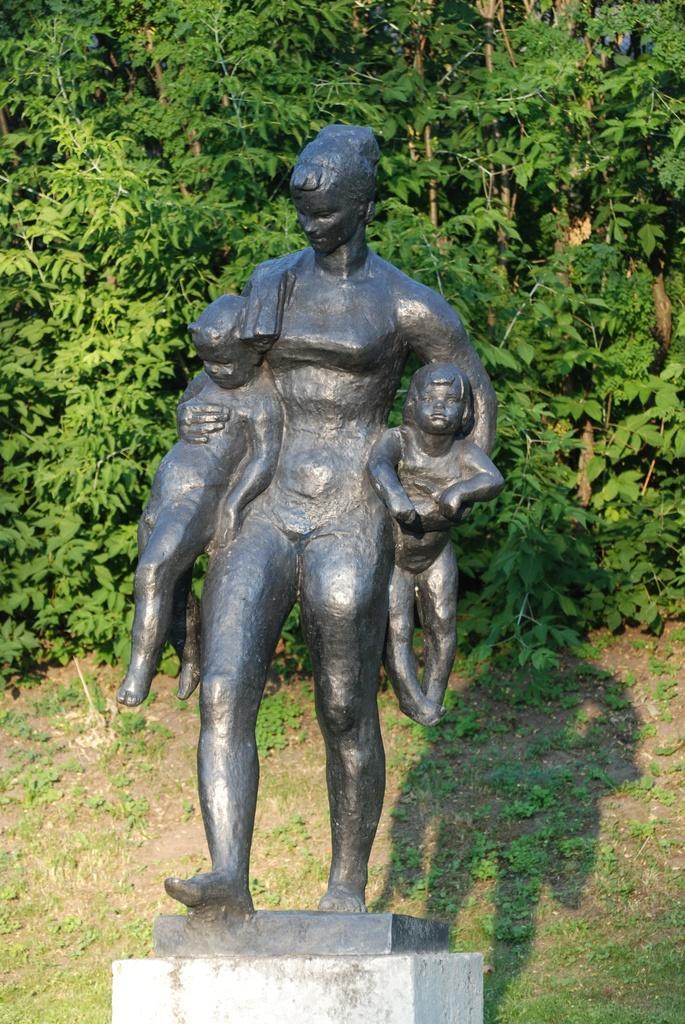Could you give a brief overview of what you see in this image? This is the sculpture of the woman holding two kids. These are the trees with branches and leaves. I can see the shadow of the sculpture. 